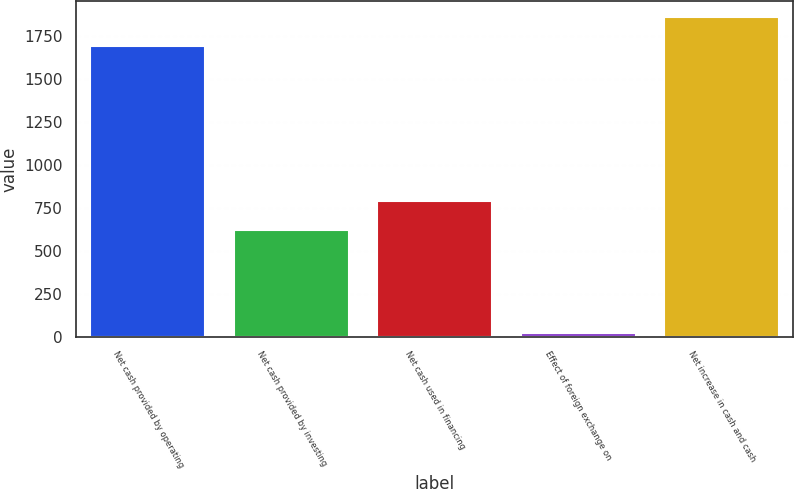Convert chart. <chart><loc_0><loc_0><loc_500><loc_500><bar_chart><fcel>Net cash provided by operating<fcel>Net cash provided by investing<fcel>Net cash used in financing<fcel>Effect of foreign exchange on<fcel>Net increase in cash and cash<nl><fcel>1692<fcel>622<fcel>789.1<fcel>22<fcel>1859.1<nl></chart> 